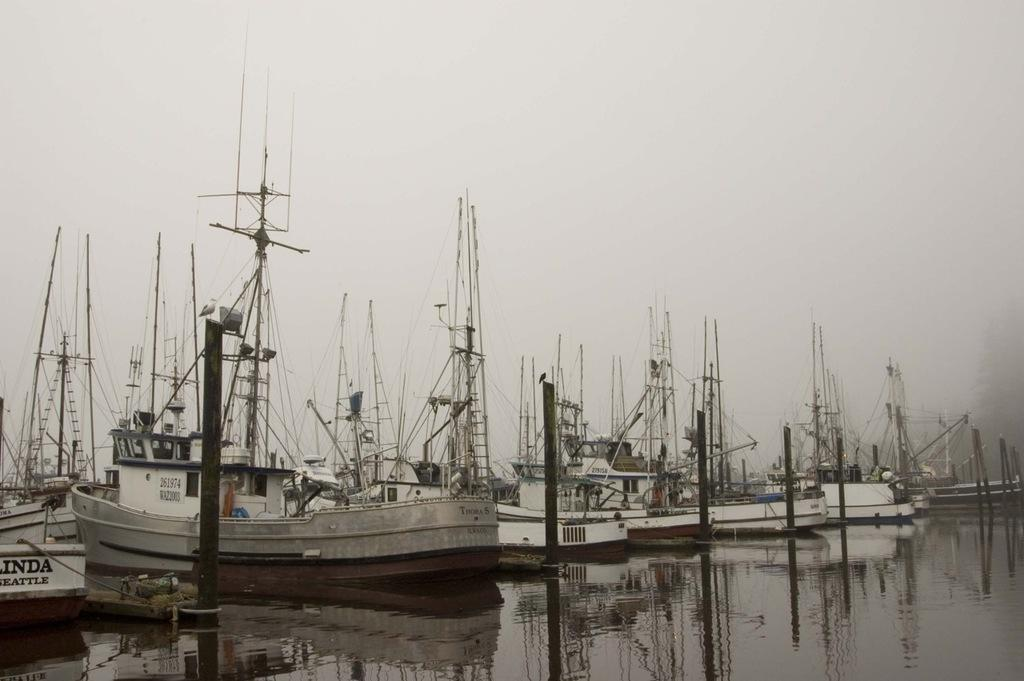Provide a one-sentence caption for the provided image. A boat sits at a dock in the water with the number 261974 visible. 